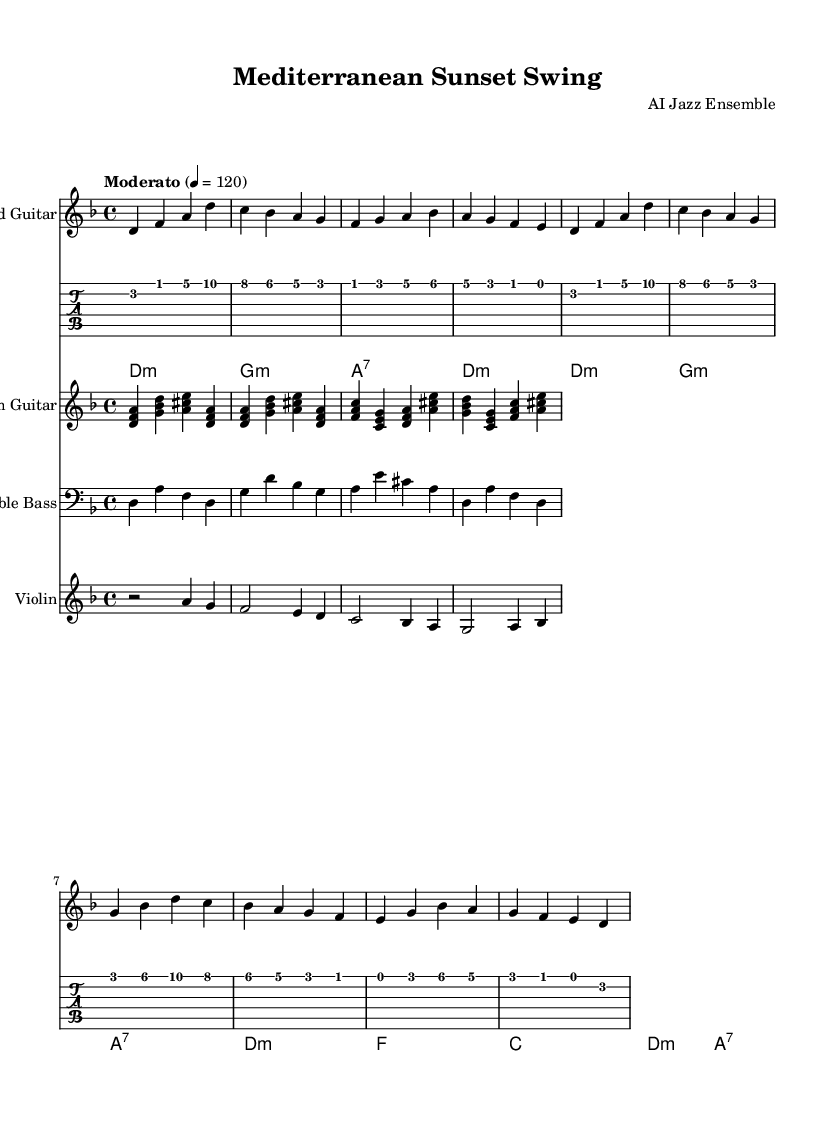What is the key signature of this music? The key signature displayed at the beginning indicates that there are one flat (B♭), which corresponds to the key of D minor.
Answer: D minor What is the time signature of this music? The time signature shown at the beginning of the score is 4/4, indicating that there are four beats per measure and a quarter note receives one beat.
Answer: 4/4 What is the tempo marking of this music? The tempo marking indicates "Moderato," along with a metronome mark of 120 beats per minute, suggesting a moderate pace.
Answer: Moderato Which instruments are featured in this piece? The score lists four instruments: Lead Guitar, Rhythm Guitar, Double Bass, and Violin. This indicates a typical setup for a jazz ensemble.
Answer: Lead Guitar, Rhythm Guitar, Double Bass, Violin Which section of the music features a counter-melody? The Violin part in the score showcases a simple counter-melody that interacts with the main lead guitar line, typical in jazz arrangements to create texture.
Answer: Violin How many measures are there in the A section? The A section consists of two complete cycles of eight measures each as noted within the provided structure, resulting in a total of sixteen measures.
Answer: Sixteen measures What type of chord is used at the beginning of the rhythm guitar part? The rhythm guitar starts with a D minor chord, as indicated by the chord notation at the beginning of the score.
Answer: D minor 